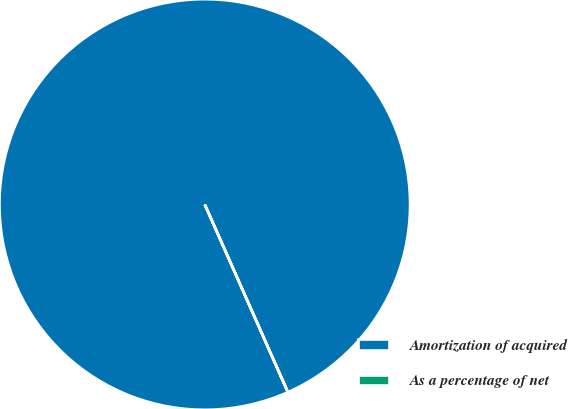Convert chart. <chart><loc_0><loc_0><loc_500><loc_500><pie_chart><fcel>Amortization of acquired<fcel>As a percentage of net<nl><fcel>100.0%<fcel>0.0%<nl></chart> 